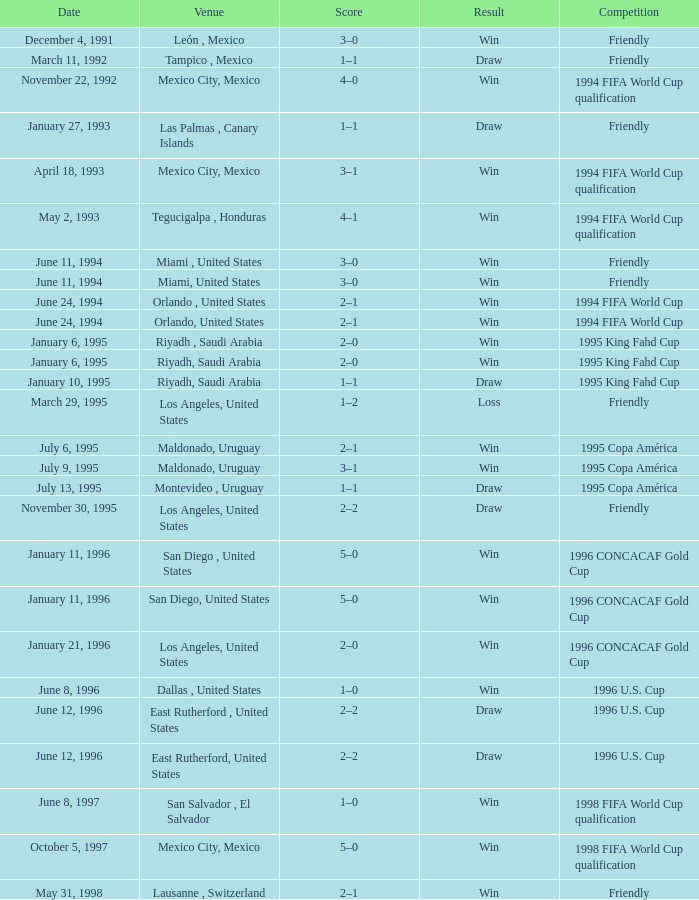What is Score, when Date is "June 8, 1996"? 1–0. 